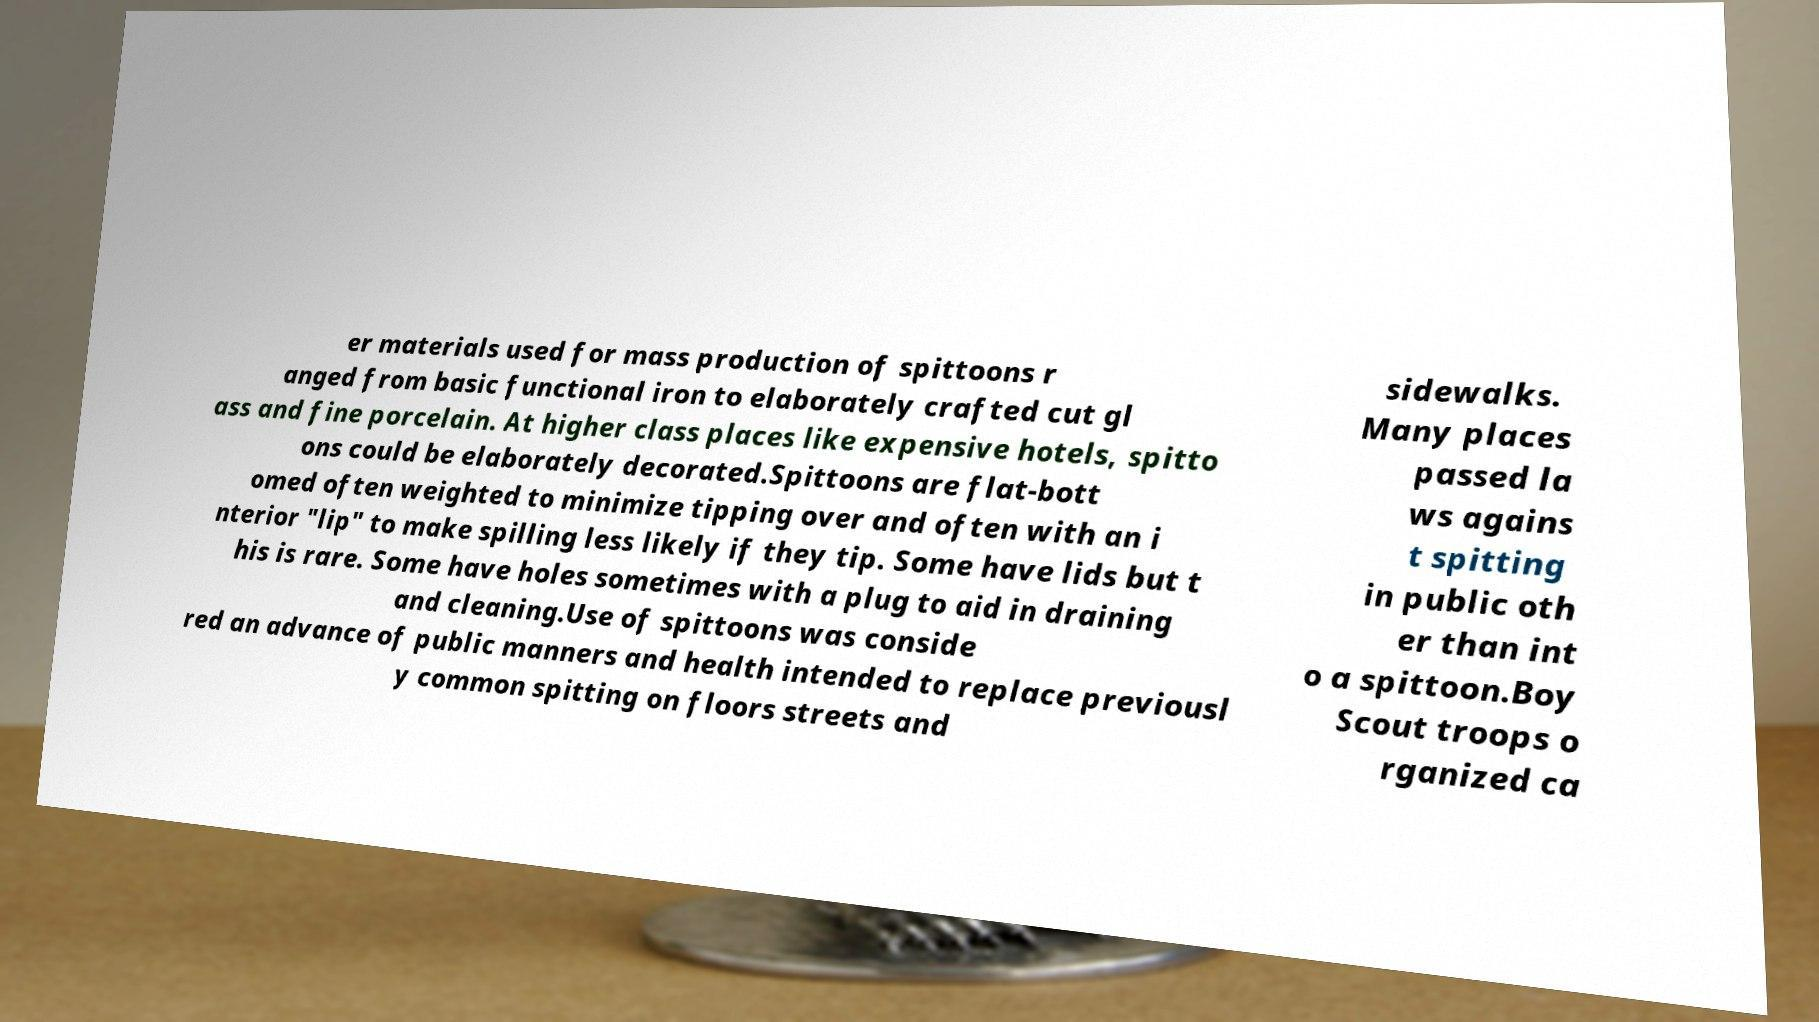There's text embedded in this image that I need extracted. Can you transcribe it verbatim? er materials used for mass production of spittoons r anged from basic functional iron to elaborately crafted cut gl ass and fine porcelain. At higher class places like expensive hotels, spitto ons could be elaborately decorated.Spittoons are flat-bott omed often weighted to minimize tipping over and often with an i nterior "lip" to make spilling less likely if they tip. Some have lids but t his is rare. Some have holes sometimes with a plug to aid in draining and cleaning.Use of spittoons was conside red an advance of public manners and health intended to replace previousl y common spitting on floors streets and sidewalks. Many places passed la ws agains t spitting in public oth er than int o a spittoon.Boy Scout troops o rganized ca 